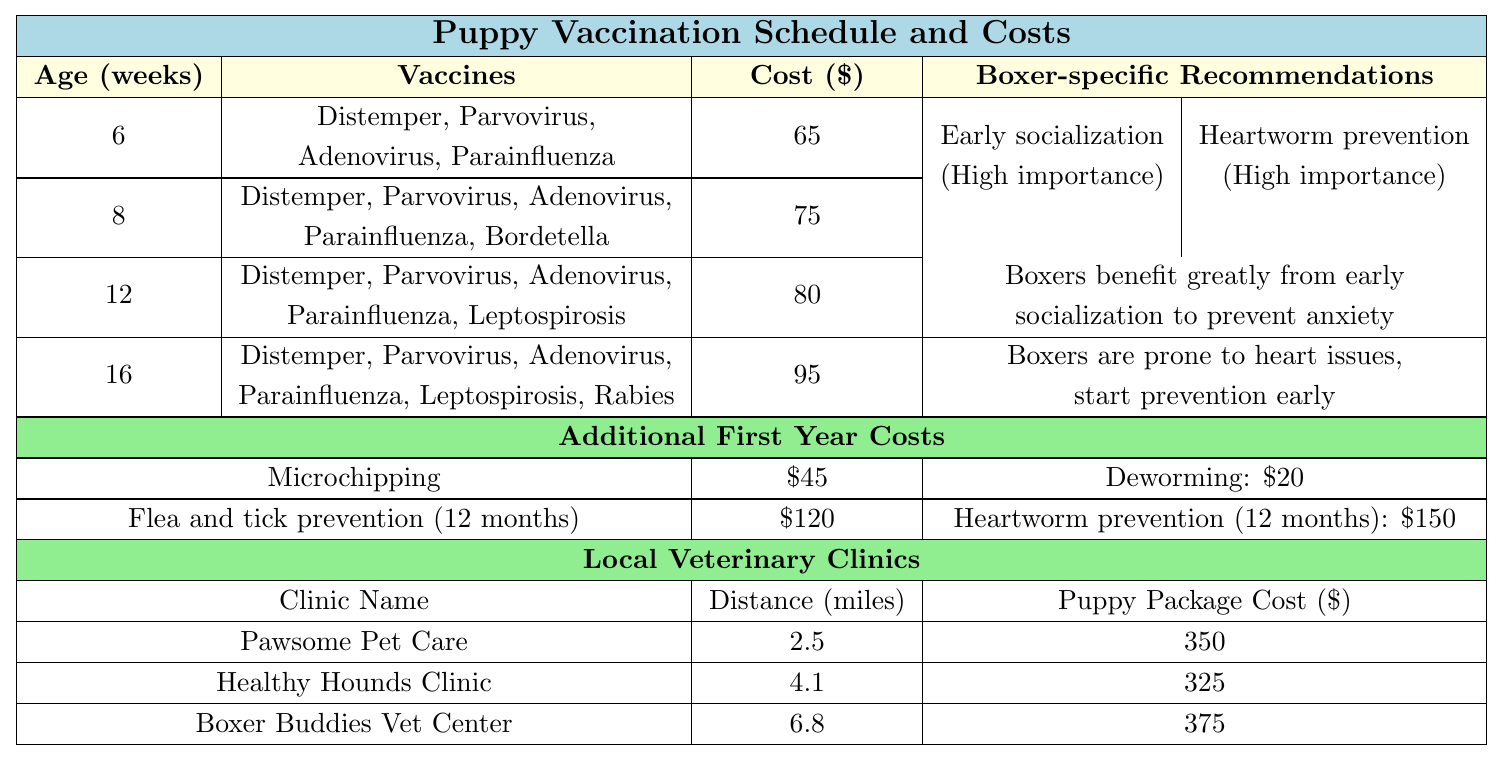What vaccines are administered at 8 weeks? The table lists the vaccines given at 8 weeks as Distemper, Parvovirus, Adenovirus, Parainfluenza, and Bordetella.
Answer: Distemper, Parvovirus, Adenovirus, Parainfluenza, Bordetella What is the total cost for all vaccinations during the first year? The costs for vaccinations at 6, 8, 12, and 16 weeks are 65, 75, 80, and 95, respectively. Adding these gives 65 + 75 + 80 + 95 = 315.
Answer: 315 Is microchipping more expensive than deworming? The cost of microchipping is 45, and deworming costs 20. Since 45 > 20, the answer is yes.
Answer: Yes What is the highest age at which rabies vaccine is given? The rabies vaccine is given at the 16-week mark. This is found in the list of vaccines for 16 weeks.
Answer: 16 weeks Which clinic is the farthest from your location? The distances from each clinic are 2.5 miles, 4.1 miles, and 6.8 miles, respectively. The furthest distance is 6.8 miles for Boxer Buddies Vet Center.
Answer: Boxer Buddies Vet Center What is the average cost of the puppy packages from the three clinics? The costs of the puppy packages are 350, 325, and 375. To find the average: (350 + 325 + 375) / 3 = 350.
Answer: 350 How many vaccines are given at 12 weeks? At 12 weeks, the vaccines listed are Distemper, Parvovirus, Adenovirus, Parainfluenza, and Leptospirosis. Counting these gives a total of 5 vaccines.
Answer: 5 vaccines What additional service costs more, flea and tick prevention or heartworm prevention? Flea and tick prevention costs 120, while heartworm prevention costs 150. Since 150 > 120, heartworm prevention is more expensive.
Answer: Heartworm prevention What is the total distance you would travel if you visit all three clinics? The distances to the clinics are 2.5 miles, 4.1 miles, and 6.8 miles. The total distance is 2.5 + 4.1 + 6.8 = 13.4 miles.
Answer: 13.4 miles Are both Boxer-specific recommendations marked as high importance? The table lists both early socialization and heartworm prevention as high importance, so the answer is yes.
Answer: Yes 